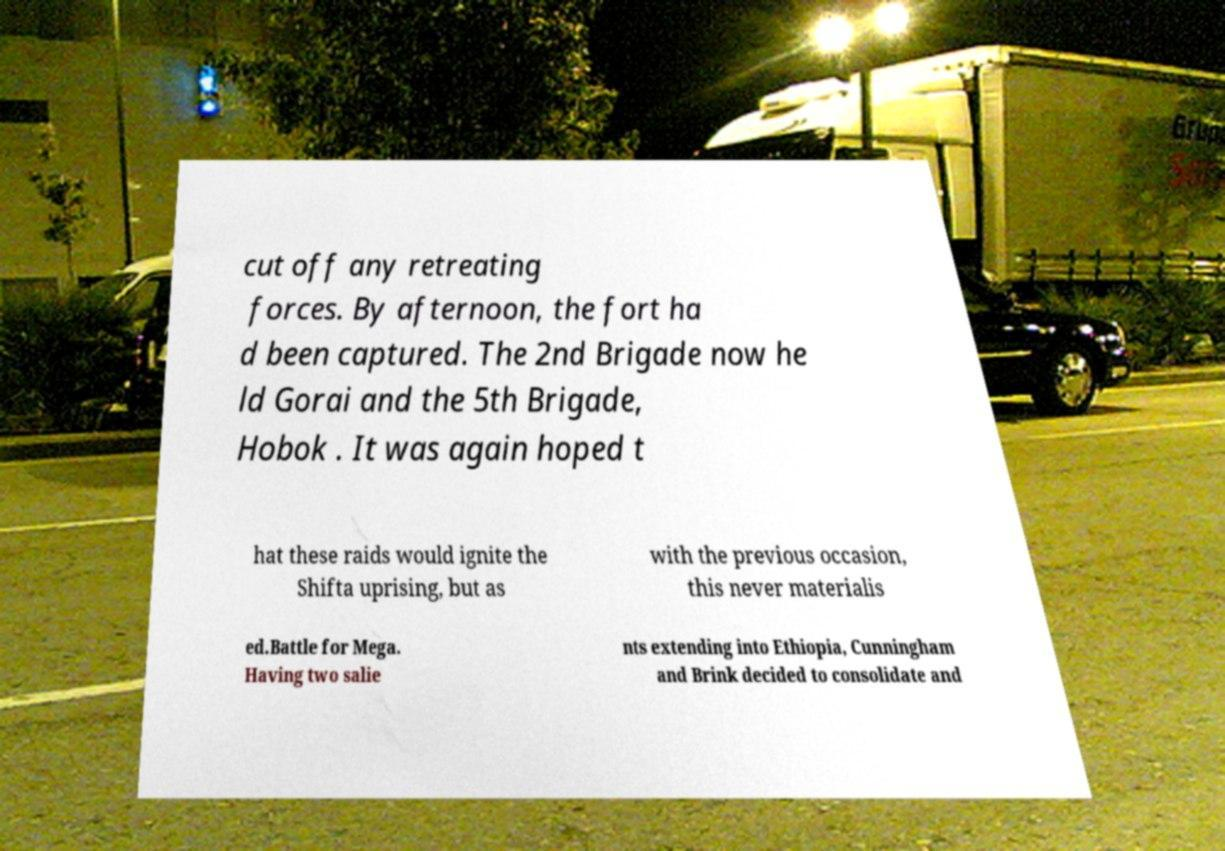Can you accurately transcribe the text from the provided image for me? cut off any retreating forces. By afternoon, the fort ha d been captured. The 2nd Brigade now he ld Gorai and the 5th Brigade, Hobok . It was again hoped t hat these raids would ignite the Shifta uprising, but as with the previous occasion, this never materialis ed.Battle for Mega. Having two salie nts extending into Ethiopia, Cunningham and Brink decided to consolidate and 